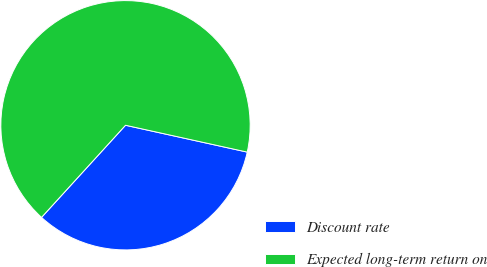Convert chart to OTSL. <chart><loc_0><loc_0><loc_500><loc_500><pie_chart><fcel>Discount rate<fcel>Expected long-term return on<nl><fcel>33.31%<fcel>66.69%<nl></chart> 